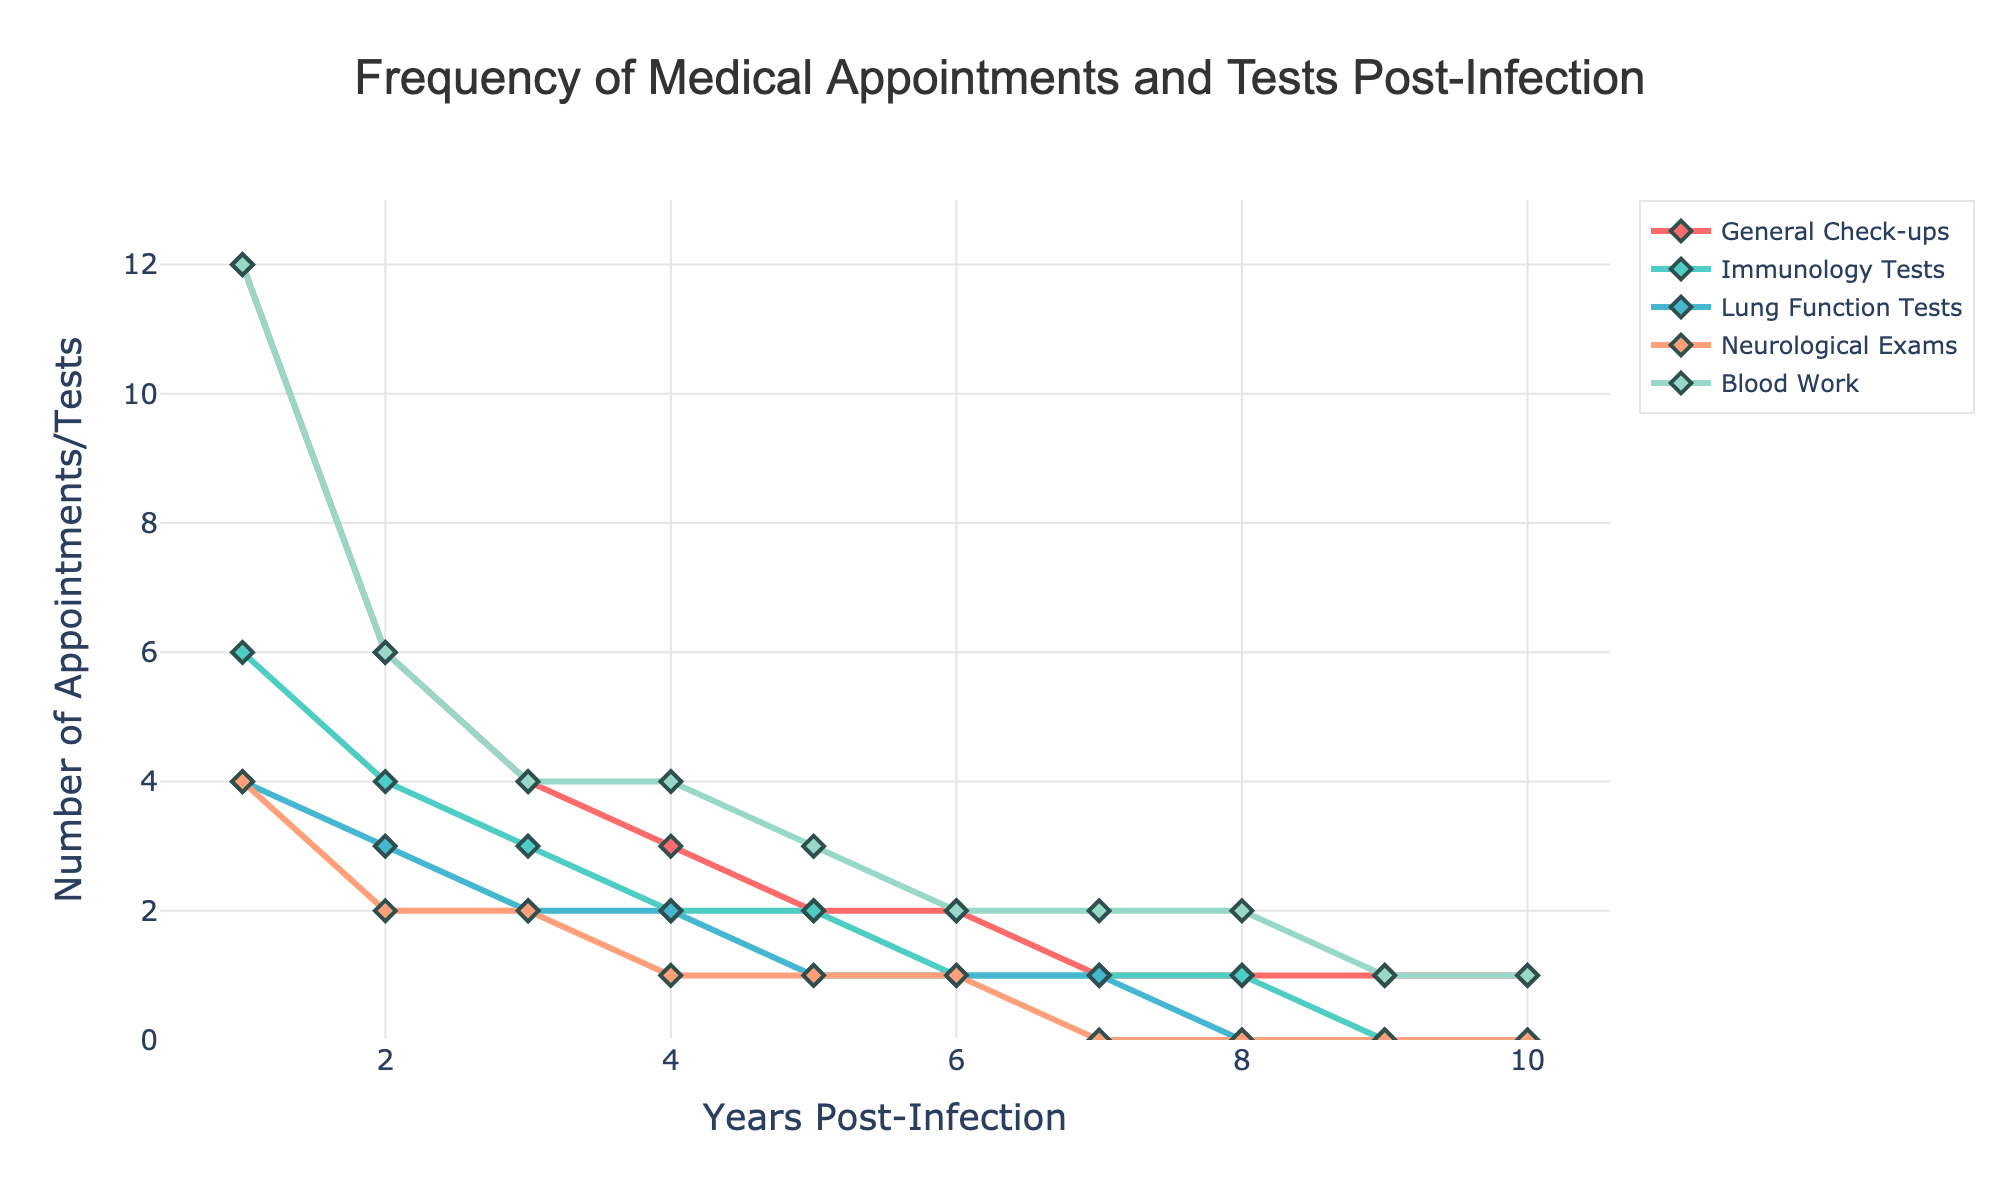what is the number of general check-ups in year 5? To determine the number of general check-ups in year 5, refer to the chart for the point which corresponds to the data for year 5 under 'General Check-ups'. The number at this point can be read directly.
Answer: 2 over which years does the number of blood work tests remain constant? To find the years when the blood work tests number is constant, follow the blood work line and identify segments that are flat. The line stays at the same height during years 6, 7, and 8.
Answer: Years 6-8 which type of test shows the steepest decline from year 1 to year 2? To find the steepest decline, compare the slopes of lines between these years. The steepest slope represents the largest drop. The Immunology Tests line shows the steepest decline.
Answer: Immunology Tests how does the number of neurological exams in year 4 compare to that in year 2? Compare the heights of the lines at years 4 and 2 for Neurological Exams. This comparison shows that Neurological Exams are lower in year 4 than in year 2.
Answer: Less among all test types, which one has the least frequency in year 7? For year 7, look at the respective values at that year across all test types. Neurological Exams have the lowest value, being 0.
Answer: Neurological Exams what is the average number of general check-ups in the first three years? Add the yearly values for General Check-ups from years 1 to 3 and divide by 3: (12 + 6 + 4) / 3 = 22 / 3.
Answer: 7.33 which test type has the most gradual decline over the 10 years? To identify the most gradual decline, observe which line descends the slowest. General Check-ups have the most gentle slope over the years.
Answer: General Check-ups in which year was there no lung function test conducted at all? Find the year(s) where the Lung Function Tests line touches zero. This occurs in years 8 and beyond.
Answer: Year 8 and beyond what is the sum of immunology tests conducted over the first five years? To find this, sum the values for Immunology Tests from years 1 to 5: (6 + 4 + 3 + 2 + 2).
Answer: 17 how many types of tests are still being routinely conducted (at least once a year) by year 10? Look at the data for year 10, checking how many test types have non-zero values. General Check-ups and Blood Work still have non-zero values.
Answer: 2 